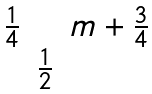Convert formula to latex. <formula><loc_0><loc_0><loc_500><loc_500>\begin{matrix} \frac { 1 } { 4 } & & m + \frac { 3 } { 4 } \\ & \frac { 1 } { 2 } & \end{matrix}</formula> 